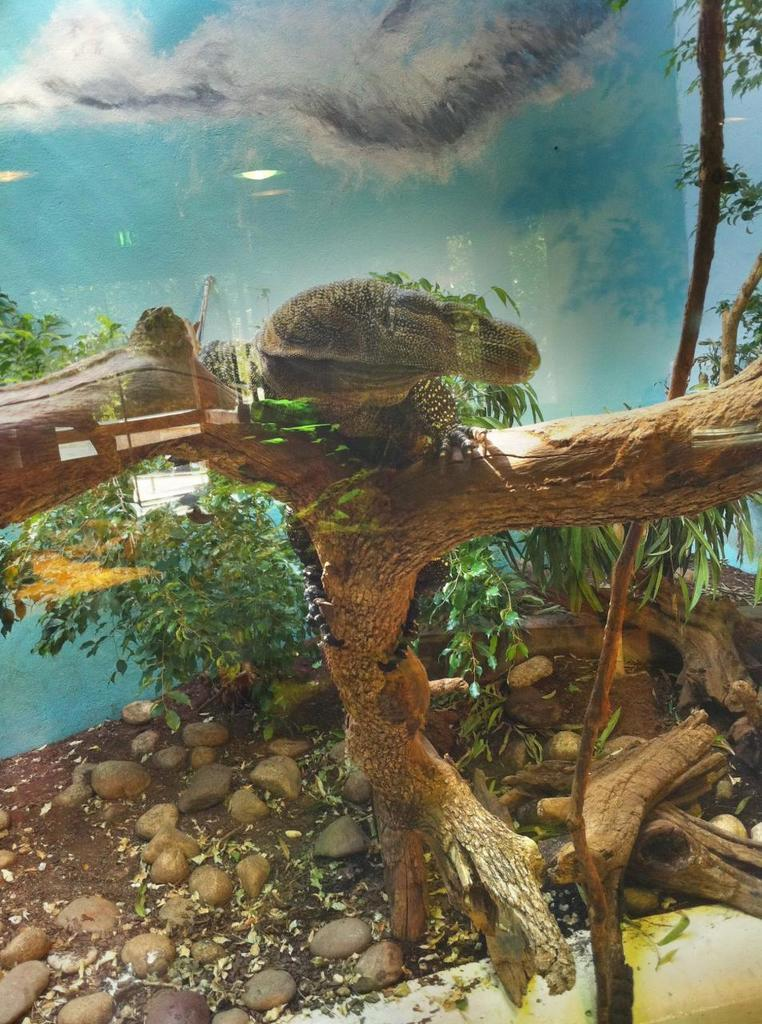What type of plant can be seen in the picture? There is a tree in the picture. What natural element is visible in the picture besides the tree? There is water visible in the picture. Can you describe the reptile in the picture? It appears that there is a reptile on the tree bark. What type of landscape feature can be seen in the picture? There are stones in the picture. What other type of plant can be seen in the picture besides the tree? There are plants in the picture. What type of punishment is being administered to the tree in the picture? There is no punishment being administered to the tree in the picture; it is a natural element in the landscape. How low is the water level in the picture? The water level is not mentioned in the facts provided, so it cannot be determined from the image. 